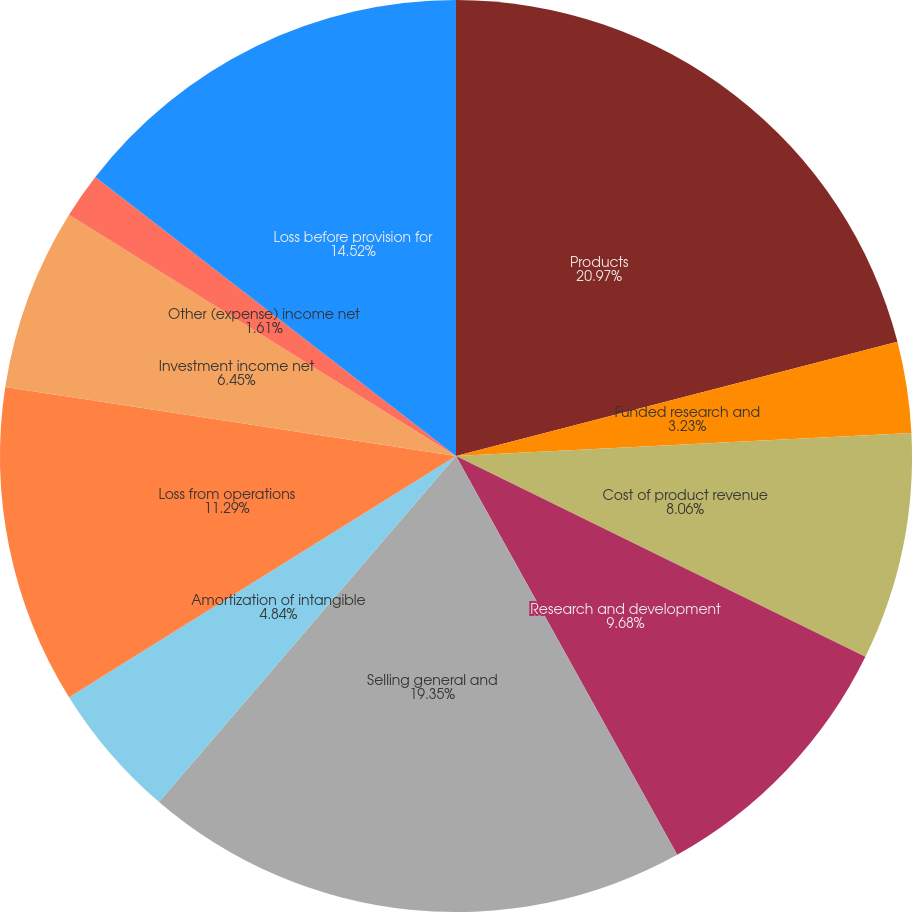Convert chart. <chart><loc_0><loc_0><loc_500><loc_500><pie_chart><fcel>Products<fcel>Funded research and<fcel>Cost of product revenue<fcel>Research and development<fcel>Selling general and<fcel>Amortization of intangible<fcel>Loss from operations<fcel>Investment income net<fcel>Other (expense) income net<fcel>Loss before provision for<nl><fcel>20.97%<fcel>3.23%<fcel>8.06%<fcel>9.68%<fcel>19.35%<fcel>4.84%<fcel>11.29%<fcel>6.45%<fcel>1.61%<fcel>14.52%<nl></chart> 